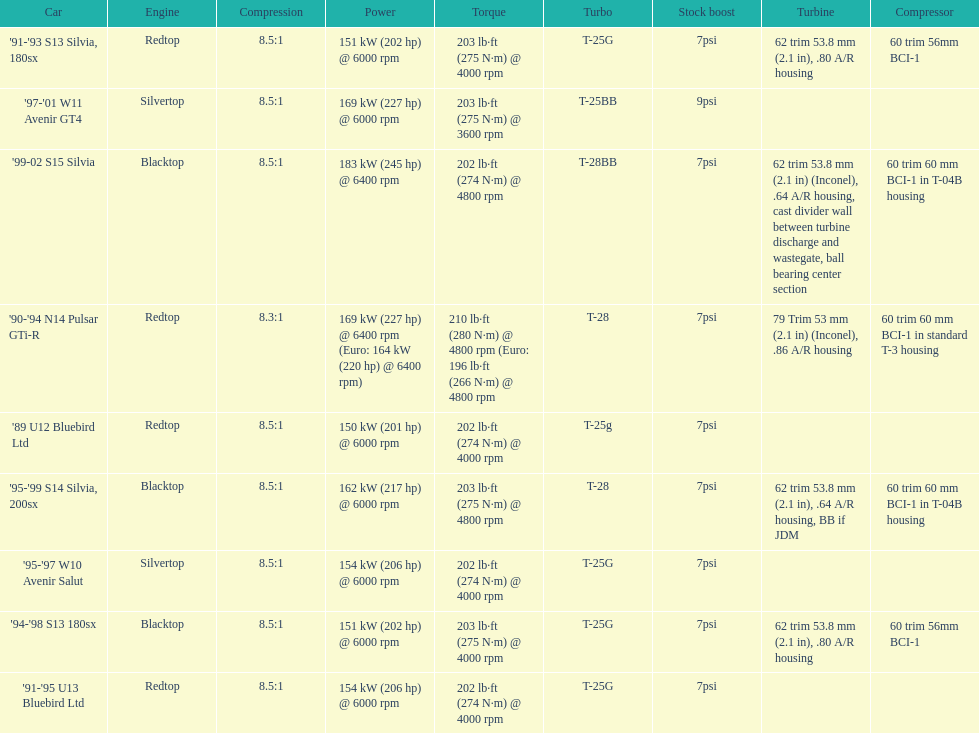Which engines were used after 1999? Silvertop, Blacktop. 